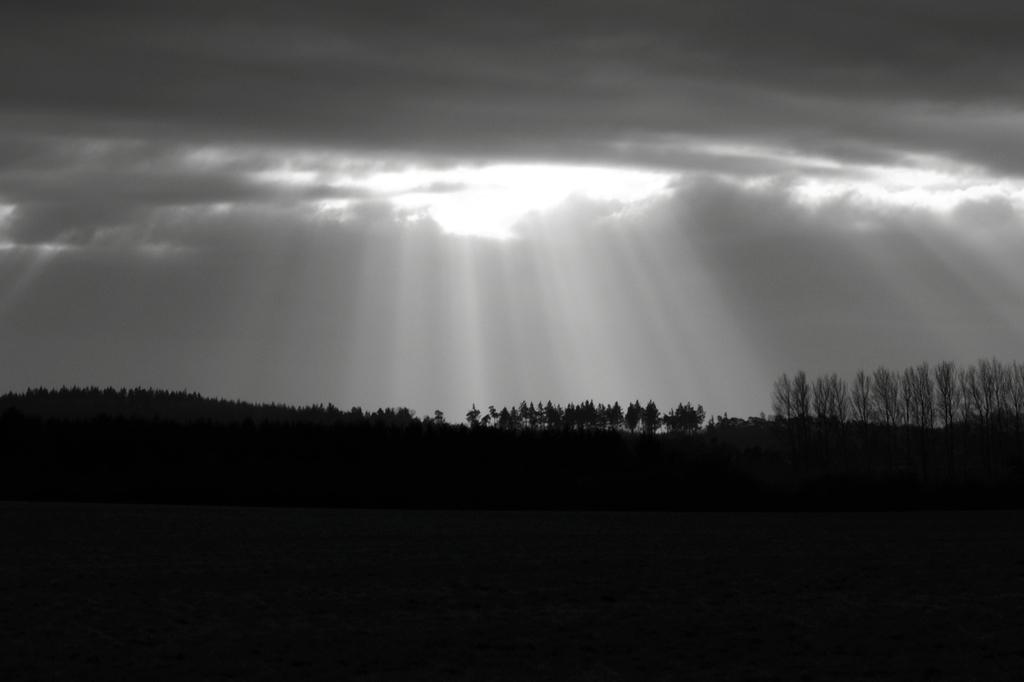What is located in the center of the image? There are trees in the center of the image. What type of landform can be seen in the image? There is a hill visible in the image. What is visible in the background of the image? The sky is visible in the background of the image. What type of fire can be seen burning on the hill in the image? There is no fire present in the image; it only features trees, a hill, and the sky. 